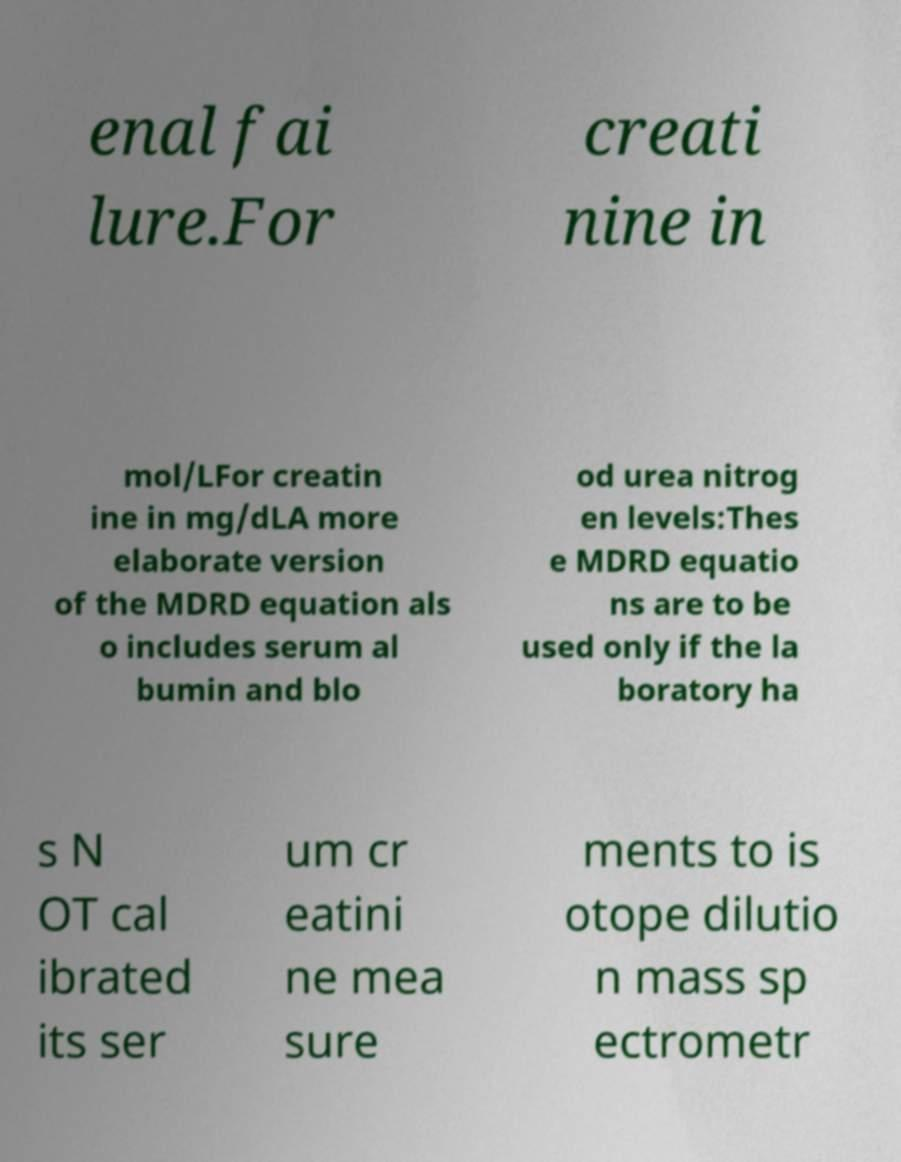What messages or text are displayed in this image? I need them in a readable, typed format. enal fai lure.For creati nine in mol/LFor creatin ine in mg/dLA more elaborate version of the MDRD equation als o includes serum al bumin and blo od urea nitrog en levels:Thes e MDRD equatio ns are to be used only if the la boratory ha s N OT cal ibrated its ser um cr eatini ne mea sure ments to is otope dilutio n mass sp ectrometr 